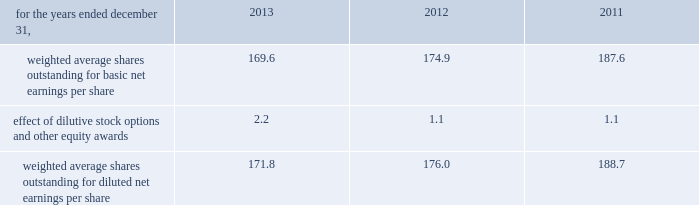Zimmer holdings , inc .
2013 form 10-k annual report notes to consolidated financial statements ( continued ) state income tax returns are generally subject to examination for a period of 3 to 5 years after filing of the respective return .
The state impact of any federal changes generally remains subject to examination by various states for a period of up to one year after formal notification to the states .
We have various state income tax returns in the process of examination , administrative appeals or litigation .
Our tax returns are currently under examination in various foreign jurisdictions .
Foreign jurisdictions have statutes of limitations generally ranging from 3 to 5 years .
Years still open to examination by foreign tax authorities in major jurisdictions include : australia ( 2009 onward ) , canada ( 2007 onward ) , france ( 2011 onward ) , germany ( 2009 onward ) , ireland ( 2009 onward ) , italy ( 2010 onward ) , japan ( 2010 onward ) , korea ( 2008 onward ) , puerto rico ( 2008 onward ) , switzerland ( 2012 onward ) , and the united kingdom ( 2012 onward ) .
16 .
Capital stock and earnings per share we are authorized to issue 250 million shares of preferred stock , none of which were issued or outstanding as of december 31 , 2013 .
The numerator for both basic and diluted earnings per share is net earnings available to common stockholders .
The denominator for basic earnings per share is the weighted average number of common shares outstanding during the period .
The denominator for diluted earnings per share is weighted average shares outstanding adjusted for the effect of dilutive stock options and other equity awards .
The following is a reconciliation of weighted average shares for the basic and diluted share computations ( in millions ) : .
Weighted average shares outstanding for basic net earnings per share 169.6 174.9 187.6 effect of dilutive stock options and other equity awards 2.2 1.1 1.1 weighted average shares outstanding for diluted net earnings per share 171.8 176.0 188.7 for the year ended december 31 , 2013 , an average of 3.1 million options to purchase shares of common stock were not included in the computation of diluted earnings per share as the exercise prices of these options were greater than the average market price of the common stock .
For the years ended december 31 , 2012 and 2011 , an average of 11.9 million and 13.2 million options , respectively , were not included .
During 2013 , we repurchased 9.1 million shares of our common stock at an average price of $ 78.88 per share for a total cash outlay of $ 719.0 million , including commissions .
Effective january 1 , 2014 , we have a new share repurchase program that authorizes purchases of up to $ 1.0 billion with no expiration date .
No further purchases will be made under the previous share repurchase program .
17 .
Segment data we design , develop , manufacture and market orthopaedic reconstructive implants , biologics , dental implants , spinal implants , trauma products and related surgical products which include surgical supplies and instruments designed to aid in surgical procedures and post-operation rehabilitation .
We also provide other healthcare-related services .
We manage operations through three major geographic segments 2013 the americas , which is comprised principally of the u.s .
And includes other north , central and south american markets ; europe , which is comprised principally of europe and includes the middle east and african markets ; and asia pacific , which is comprised primarily of japan and includes other asian and pacific markets .
This structure is the basis for our reportable segment information discussed below .
Management evaluates reportable segment performance based upon segment operating profit exclusive of operating expenses pertaining to share-based payment expense , inventory step-up and certain other inventory and manufacturing related charges , 201ccertain claims , 201d goodwill impairment , 201cspecial items , 201d and global operations and corporate functions .
Global operations and corporate functions include research , development engineering , medical education , brand management , corporate legal , finance , and human resource functions , u.s. , puerto rico and ireland-based manufacturing operations and logistics and intangible asset amortization resulting from business combination accounting .
Intercompany transactions have been eliminated from segment operating profit .
Management reviews accounts receivable , inventory , property , plant and equipment , goodwill and intangible assets by reportable segment exclusive of u.s. , puerto rico and ireland-based manufacturing operations and logistics and corporate assets. .
What percent increase does dilutive stock have on the value of weighted shares outstanding for earnings per share in 2013? 
Computations: ((171.8 / 169.6) - 1)
Answer: 0.01297. Zimmer holdings , inc .
2013 form 10-k annual report notes to consolidated financial statements ( continued ) state income tax returns are generally subject to examination for a period of 3 to 5 years after filing of the respective return .
The state impact of any federal changes generally remains subject to examination by various states for a period of up to one year after formal notification to the states .
We have various state income tax returns in the process of examination , administrative appeals or litigation .
Our tax returns are currently under examination in various foreign jurisdictions .
Foreign jurisdictions have statutes of limitations generally ranging from 3 to 5 years .
Years still open to examination by foreign tax authorities in major jurisdictions include : australia ( 2009 onward ) , canada ( 2007 onward ) , france ( 2011 onward ) , germany ( 2009 onward ) , ireland ( 2009 onward ) , italy ( 2010 onward ) , japan ( 2010 onward ) , korea ( 2008 onward ) , puerto rico ( 2008 onward ) , switzerland ( 2012 onward ) , and the united kingdom ( 2012 onward ) .
16 .
Capital stock and earnings per share we are authorized to issue 250 million shares of preferred stock , none of which were issued or outstanding as of december 31 , 2013 .
The numerator for both basic and diluted earnings per share is net earnings available to common stockholders .
The denominator for basic earnings per share is the weighted average number of common shares outstanding during the period .
The denominator for diluted earnings per share is weighted average shares outstanding adjusted for the effect of dilutive stock options and other equity awards .
The following is a reconciliation of weighted average shares for the basic and diluted share computations ( in millions ) : .
Weighted average shares outstanding for basic net earnings per share 169.6 174.9 187.6 effect of dilutive stock options and other equity awards 2.2 1.1 1.1 weighted average shares outstanding for diluted net earnings per share 171.8 176.0 188.7 for the year ended december 31 , 2013 , an average of 3.1 million options to purchase shares of common stock were not included in the computation of diluted earnings per share as the exercise prices of these options were greater than the average market price of the common stock .
For the years ended december 31 , 2012 and 2011 , an average of 11.9 million and 13.2 million options , respectively , were not included .
During 2013 , we repurchased 9.1 million shares of our common stock at an average price of $ 78.88 per share for a total cash outlay of $ 719.0 million , including commissions .
Effective january 1 , 2014 , we have a new share repurchase program that authorizes purchases of up to $ 1.0 billion with no expiration date .
No further purchases will be made under the previous share repurchase program .
17 .
Segment data we design , develop , manufacture and market orthopaedic reconstructive implants , biologics , dental implants , spinal implants , trauma products and related surgical products which include surgical supplies and instruments designed to aid in surgical procedures and post-operation rehabilitation .
We also provide other healthcare-related services .
We manage operations through three major geographic segments 2013 the americas , which is comprised principally of the u.s .
And includes other north , central and south american markets ; europe , which is comprised principally of europe and includes the middle east and african markets ; and asia pacific , which is comprised primarily of japan and includes other asian and pacific markets .
This structure is the basis for our reportable segment information discussed below .
Management evaluates reportable segment performance based upon segment operating profit exclusive of operating expenses pertaining to share-based payment expense , inventory step-up and certain other inventory and manufacturing related charges , 201ccertain claims , 201d goodwill impairment , 201cspecial items , 201d and global operations and corporate functions .
Global operations and corporate functions include research , development engineering , medical education , brand management , corporate legal , finance , and human resource functions , u.s. , puerto rico and ireland-based manufacturing operations and logistics and intangible asset amortization resulting from business combination accounting .
Intercompany transactions have been eliminated from segment operating profit .
Management reviews accounts receivable , inventory , property , plant and equipment , goodwill and intangible assets by reportable segment exclusive of u.s. , puerto rico and ireland-based manufacturing operations and logistics and corporate assets. .
What was the change in millions of weighted average shares outstanding for diluted net earnings per share between 2012 and 2013? 
Computations: (171.8 - 176.0)
Answer: -4.2. 